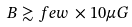Convert formula to latex. <formula><loc_0><loc_0><loc_500><loc_500>B \gtrsim f e w \, \times 1 0 \mu G</formula> 